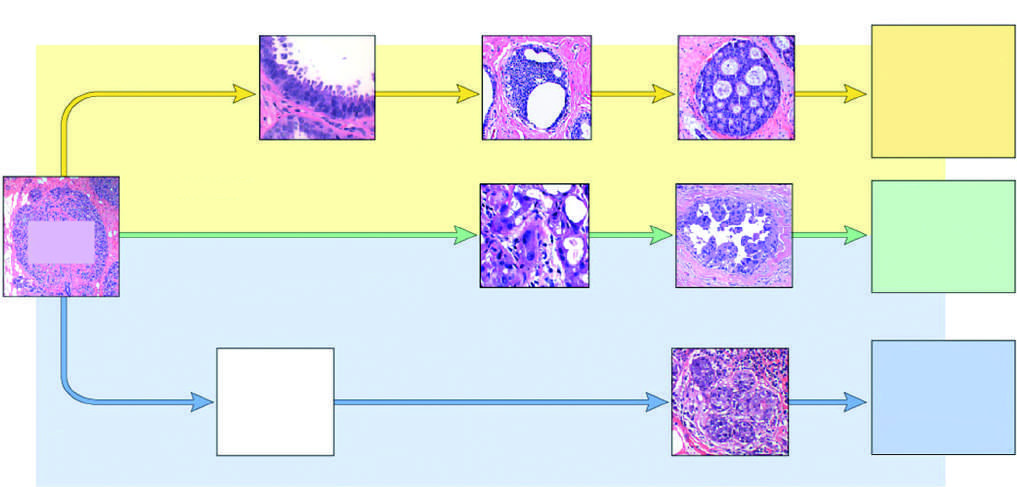s the least common but molecularly most distinctive type of breast cancer negative for er and her2 triple negative ; blue arrow?
Answer the question using a single word or phrase. Yes 